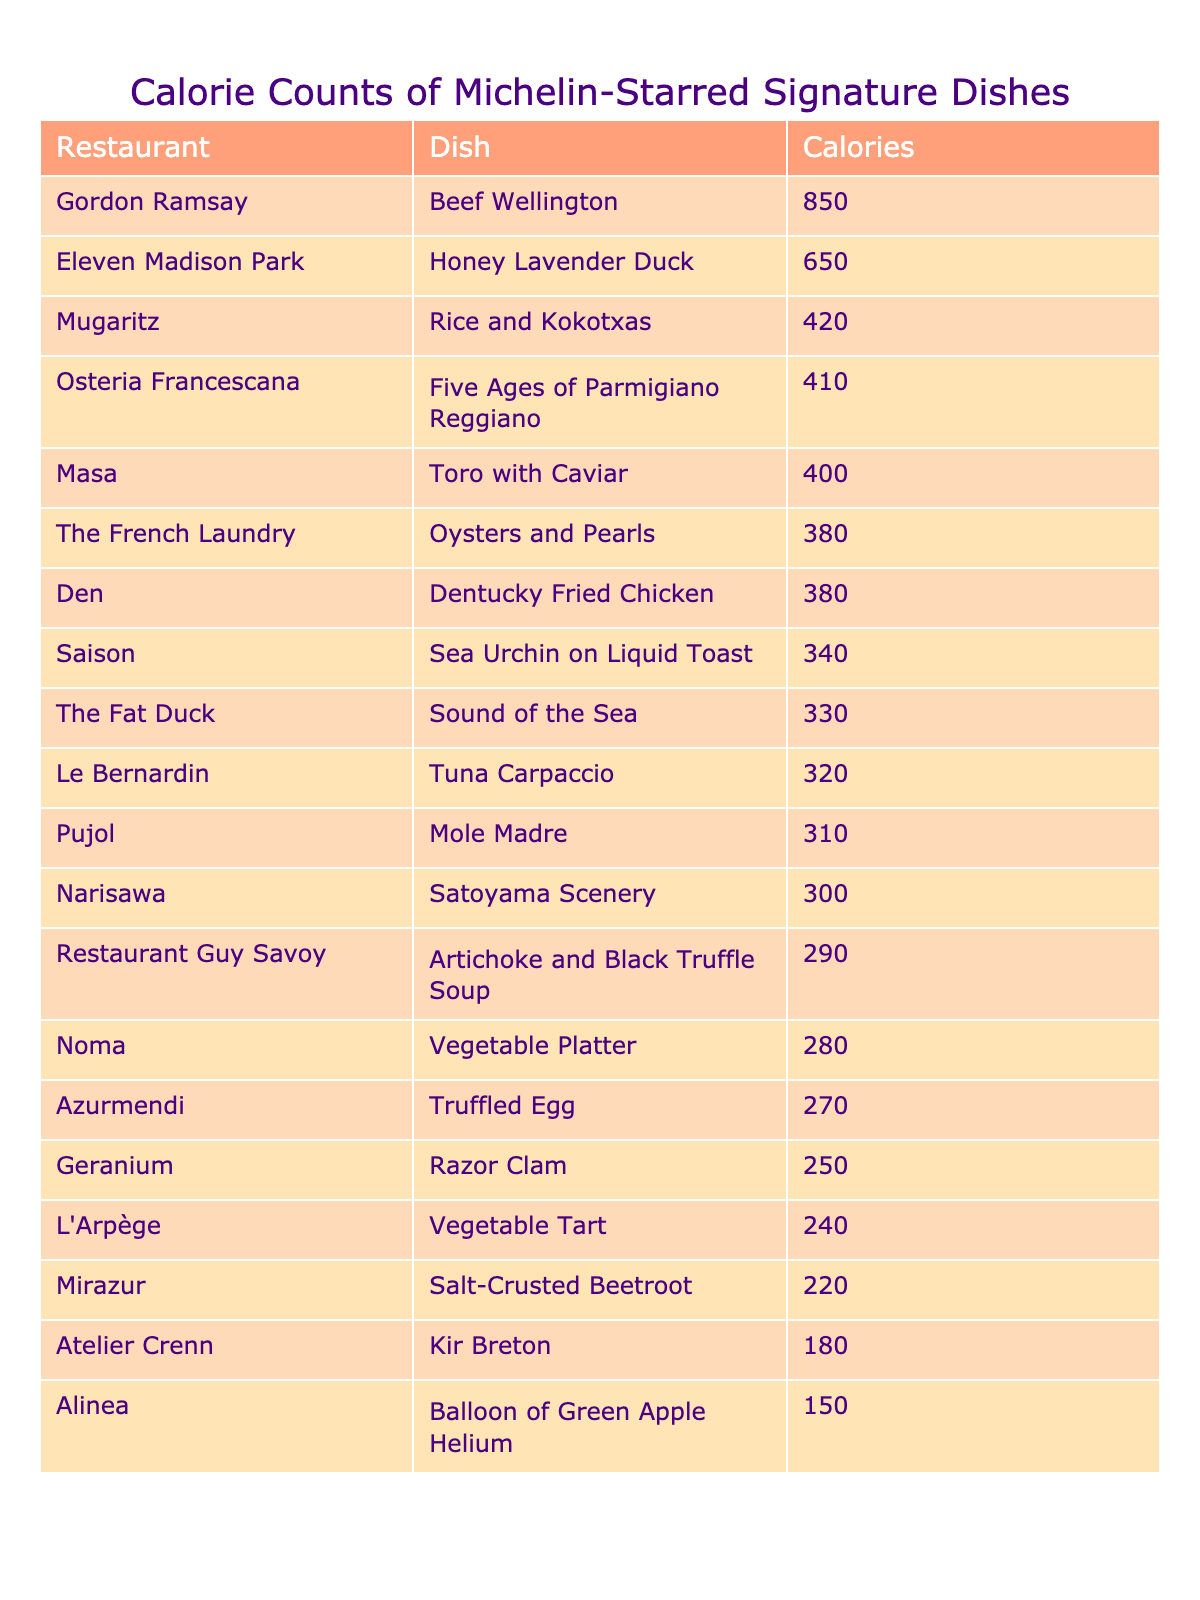What is the lowest calorie dish listed? The lowest calorie dish is found by scanning the Calories column for the minimum value. Upon inspection, the dish "Balloon of Green Apple Helium" from Alinea has the lowest calorie count of 150.
Answer: 150 Which dish has the highest calorie count? To find the highest calorie dish, we look for the maximum value in the Calories column. The dish "Beef Wellington" from Gordon Ramsay has the highest calorie count of 850.
Answer: 850 What is the average calorie count of the dishes? First, we need to sum the calorie counts of all dishes: 320 + 150 + 380 + 650 + 850 + 410 + 280 + 330 + 220 + 290 + 400 + 180 + 250 + 300 + 420 + 270 + 380 + 340 + 310 + 240 = 6,300. There are 20 dishes, so the average is 6,300 / 20 = 315.
Answer: 315 Does any dish have a calorie count of exactly 300? We examine the Calories column to check for the existence of the exact value of 300. "Satoyama Scenery" from Narisawa has a calorie count of 300, confirming that at least one dish meets this criterion.
Answer: Yes What is the difference in calories between the highest and lowest calorie dishes? The highest calorie dish is "Beef Wellington" at 850, and the lowest is "Balloon of Green Apple Helium" at 150. The difference is calculated as 850 - 150 = 700.
Answer: 700 How many dishes have a calorie count above 400? We count the dishes with calories greater than 400: "Beef Wellington" (850), "Honey Lavender Duck" (650), "Rice and Kokotxas" (420). This makes a total of 3 dishes.
Answer: 3 Which restaurant offers the dish with the second highest calorie count? The dish with the second highest calorie count is "Honey Lavender Duck" with 650 calories from Eleven Madison Park. After identifying the top two calorie counts, we can confirm the restaurant associated with the second highest.
Answer: Eleven Madison Park Are there more dishes above or below the average calorie count? With an average of 315, we can count the dishes above and below this value. Above 315: "Beef Wellington" (850), "Honey Lavender Duck" (650), "Five Ages of Parmigiano Reggiano" (410), and "Rice and Kokotxas" (420) give us 4 dishes. Below 315: "Tuna Carpaccio" (320), "Vegetable Platter" (280), "Sound of the Sea" (330), "Salt-Crusted Beetroot" (220), "Artichoke and Black Truffle Soup" (290), "Toro with Caviar" (400), "Kir Breton" (180), "Razor Clam" (250), "Mole Madre" (310), and "Vegetable Tart" (240) gives us 10 dishes. Since 10 is greater than 4, more dishes are below the average.
Answer: Below What percentage of dishes have a calorie count below 300? Counting the dishes below 300: "Balloon of Green Apple Helium" (150), "Salt-Crusted Beetroot" (220), "Vegetable Platter" (280), "Kir Breton" (180), "Razor Clam" (250), and "Vegetable Tart" (240) gives us 6 dishes. There are 20 total dishes, so the percentage is (6/20) * 100 = 30%.
Answer: 30% 